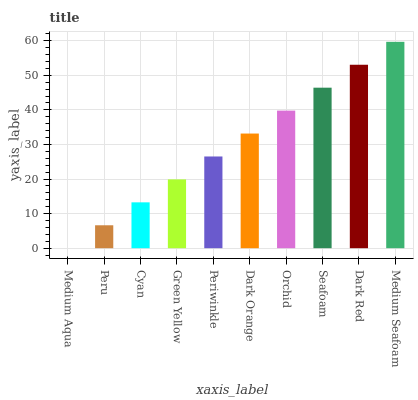Is Medium Aqua the minimum?
Answer yes or no. Yes. Is Medium Seafoam the maximum?
Answer yes or no. Yes. Is Peru the minimum?
Answer yes or no. No. Is Peru the maximum?
Answer yes or no. No. Is Peru greater than Medium Aqua?
Answer yes or no. Yes. Is Medium Aqua less than Peru?
Answer yes or no. Yes. Is Medium Aqua greater than Peru?
Answer yes or no. No. Is Peru less than Medium Aqua?
Answer yes or no. No. Is Dark Orange the high median?
Answer yes or no. Yes. Is Periwinkle the low median?
Answer yes or no. Yes. Is Medium Aqua the high median?
Answer yes or no. No. Is Dark Red the low median?
Answer yes or no. No. 